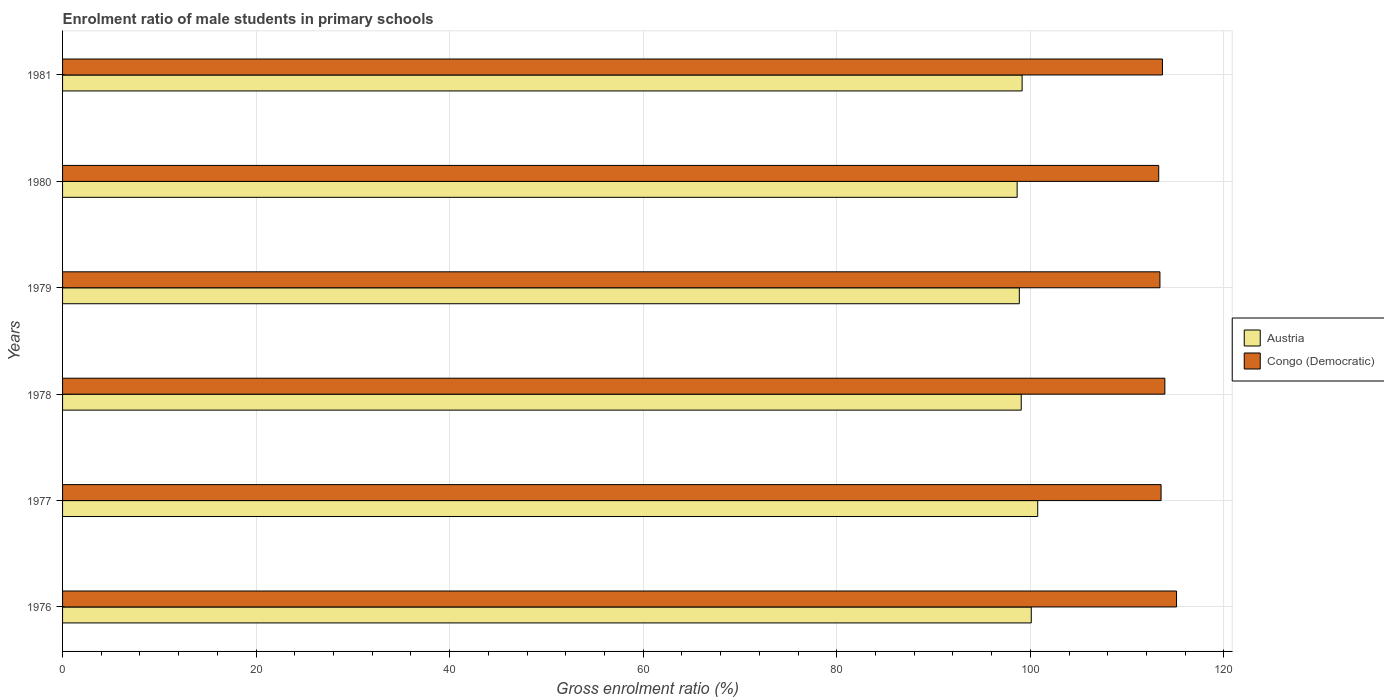Are the number of bars per tick equal to the number of legend labels?
Provide a short and direct response. Yes. Are the number of bars on each tick of the Y-axis equal?
Your response must be concise. Yes. How many bars are there on the 4th tick from the bottom?
Ensure brevity in your answer.  2. What is the label of the 4th group of bars from the top?
Provide a succinct answer. 1978. In how many cases, is the number of bars for a given year not equal to the number of legend labels?
Provide a succinct answer. 0. What is the enrolment ratio of male students in primary schools in Austria in 1981?
Give a very brief answer. 99.15. Across all years, what is the maximum enrolment ratio of male students in primary schools in Congo (Democratic)?
Offer a terse response. 115.11. Across all years, what is the minimum enrolment ratio of male students in primary schools in Austria?
Keep it short and to the point. 98.64. In which year was the enrolment ratio of male students in primary schools in Austria minimum?
Keep it short and to the point. 1980. What is the total enrolment ratio of male students in primary schools in Austria in the graph?
Your answer should be compact. 596.57. What is the difference between the enrolment ratio of male students in primary schools in Austria in 1976 and that in 1979?
Your answer should be compact. 1.24. What is the difference between the enrolment ratio of male students in primary schools in Congo (Democratic) in 1980 and the enrolment ratio of male students in primary schools in Austria in 1976?
Give a very brief answer. 13.17. What is the average enrolment ratio of male students in primary schools in Austria per year?
Make the answer very short. 99.43. In the year 1980, what is the difference between the enrolment ratio of male students in primary schools in Congo (Democratic) and enrolment ratio of male students in primary schools in Austria?
Provide a succinct answer. 14.63. In how many years, is the enrolment ratio of male students in primary schools in Congo (Democratic) greater than 88 %?
Your response must be concise. 6. What is the ratio of the enrolment ratio of male students in primary schools in Austria in 1979 to that in 1980?
Your response must be concise. 1. Is the enrolment ratio of male students in primary schools in Congo (Democratic) in 1978 less than that in 1980?
Your response must be concise. No. Is the difference between the enrolment ratio of male students in primary schools in Congo (Democratic) in 1976 and 1977 greater than the difference between the enrolment ratio of male students in primary schools in Austria in 1976 and 1977?
Ensure brevity in your answer.  Yes. What is the difference between the highest and the second highest enrolment ratio of male students in primary schools in Congo (Democratic)?
Provide a short and direct response. 1.21. What is the difference between the highest and the lowest enrolment ratio of male students in primary schools in Austria?
Your answer should be compact. 2.13. Is the sum of the enrolment ratio of male students in primary schools in Congo (Democratic) in 1976 and 1979 greater than the maximum enrolment ratio of male students in primary schools in Austria across all years?
Your answer should be very brief. Yes. What does the 1st bar from the top in 1980 represents?
Keep it short and to the point. Congo (Democratic). What does the 1st bar from the bottom in 1976 represents?
Provide a short and direct response. Austria. Are all the bars in the graph horizontal?
Keep it short and to the point. Yes. How many years are there in the graph?
Offer a very short reply. 6. What is the difference between two consecutive major ticks on the X-axis?
Provide a succinct answer. 20. Are the values on the major ticks of X-axis written in scientific E-notation?
Your response must be concise. No. Does the graph contain grids?
Provide a succinct answer. Yes. How many legend labels are there?
Offer a very short reply. 2. What is the title of the graph?
Make the answer very short. Enrolment ratio of male students in primary schools. What is the label or title of the Y-axis?
Keep it short and to the point. Years. What is the Gross enrolment ratio (%) of Austria in 1976?
Your answer should be very brief. 100.1. What is the Gross enrolment ratio (%) of Congo (Democratic) in 1976?
Provide a short and direct response. 115.11. What is the Gross enrolment ratio (%) of Austria in 1977?
Provide a succinct answer. 100.76. What is the Gross enrolment ratio (%) in Congo (Democratic) in 1977?
Keep it short and to the point. 113.51. What is the Gross enrolment ratio (%) in Austria in 1978?
Offer a terse response. 99.06. What is the Gross enrolment ratio (%) in Congo (Democratic) in 1978?
Your response must be concise. 113.9. What is the Gross enrolment ratio (%) of Austria in 1979?
Ensure brevity in your answer.  98.86. What is the Gross enrolment ratio (%) in Congo (Democratic) in 1979?
Make the answer very short. 113.39. What is the Gross enrolment ratio (%) in Austria in 1980?
Provide a succinct answer. 98.64. What is the Gross enrolment ratio (%) in Congo (Democratic) in 1980?
Your answer should be compact. 113.27. What is the Gross enrolment ratio (%) in Austria in 1981?
Provide a short and direct response. 99.15. What is the Gross enrolment ratio (%) of Congo (Democratic) in 1981?
Offer a terse response. 113.65. Across all years, what is the maximum Gross enrolment ratio (%) in Austria?
Keep it short and to the point. 100.76. Across all years, what is the maximum Gross enrolment ratio (%) in Congo (Democratic)?
Ensure brevity in your answer.  115.11. Across all years, what is the minimum Gross enrolment ratio (%) in Austria?
Ensure brevity in your answer.  98.64. Across all years, what is the minimum Gross enrolment ratio (%) in Congo (Democratic)?
Give a very brief answer. 113.27. What is the total Gross enrolment ratio (%) in Austria in the graph?
Offer a terse response. 596.57. What is the total Gross enrolment ratio (%) in Congo (Democratic) in the graph?
Your response must be concise. 682.83. What is the difference between the Gross enrolment ratio (%) in Austria in 1976 and that in 1977?
Provide a short and direct response. -0.67. What is the difference between the Gross enrolment ratio (%) of Congo (Democratic) in 1976 and that in 1977?
Offer a terse response. 1.6. What is the difference between the Gross enrolment ratio (%) in Austria in 1976 and that in 1978?
Provide a succinct answer. 1.04. What is the difference between the Gross enrolment ratio (%) of Congo (Democratic) in 1976 and that in 1978?
Keep it short and to the point. 1.21. What is the difference between the Gross enrolment ratio (%) in Austria in 1976 and that in 1979?
Your answer should be very brief. 1.24. What is the difference between the Gross enrolment ratio (%) in Congo (Democratic) in 1976 and that in 1979?
Your response must be concise. 1.72. What is the difference between the Gross enrolment ratio (%) of Austria in 1976 and that in 1980?
Your answer should be compact. 1.46. What is the difference between the Gross enrolment ratio (%) in Congo (Democratic) in 1976 and that in 1980?
Your answer should be very brief. 1.84. What is the difference between the Gross enrolment ratio (%) of Austria in 1976 and that in 1981?
Give a very brief answer. 0.94. What is the difference between the Gross enrolment ratio (%) of Congo (Democratic) in 1976 and that in 1981?
Keep it short and to the point. 1.45. What is the difference between the Gross enrolment ratio (%) in Austria in 1977 and that in 1978?
Offer a terse response. 1.7. What is the difference between the Gross enrolment ratio (%) in Congo (Democratic) in 1977 and that in 1978?
Your answer should be compact. -0.39. What is the difference between the Gross enrolment ratio (%) of Austria in 1977 and that in 1979?
Offer a very short reply. 1.9. What is the difference between the Gross enrolment ratio (%) in Congo (Democratic) in 1977 and that in 1979?
Your answer should be very brief. 0.12. What is the difference between the Gross enrolment ratio (%) in Austria in 1977 and that in 1980?
Provide a succinct answer. 2.13. What is the difference between the Gross enrolment ratio (%) of Congo (Democratic) in 1977 and that in 1980?
Ensure brevity in your answer.  0.24. What is the difference between the Gross enrolment ratio (%) of Austria in 1977 and that in 1981?
Offer a very short reply. 1.61. What is the difference between the Gross enrolment ratio (%) in Congo (Democratic) in 1977 and that in 1981?
Offer a terse response. -0.14. What is the difference between the Gross enrolment ratio (%) of Austria in 1978 and that in 1979?
Make the answer very short. 0.2. What is the difference between the Gross enrolment ratio (%) of Congo (Democratic) in 1978 and that in 1979?
Give a very brief answer. 0.51. What is the difference between the Gross enrolment ratio (%) of Austria in 1978 and that in 1980?
Ensure brevity in your answer.  0.42. What is the difference between the Gross enrolment ratio (%) of Congo (Democratic) in 1978 and that in 1980?
Your answer should be very brief. 0.63. What is the difference between the Gross enrolment ratio (%) in Austria in 1978 and that in 1981?
Your answer should be very brief. -0.09. What is the difference between the Gross enrolment ratio (%) of Congo (Democratic) in 1978 and that in 1981?
Ensure brevity in your answer.  0.25. What is the difference between the Gross enrolment ratio (%) in Austria in 1979 and that in 1980?
Offer a terse response. 0.22. What is the difference between the Gross enrolment ratio (%) of Congo (Democratic) in 1979 and that in 1980?
Your answer should be compact. 0.13. What is the difference between the Gross enrolment ratio (%) in Austria in 1979 and that in 1981?
Give a very brief answer. -0.29. What is the difference between the Gross enrolment ratio (%) in Congo (Democratic) in 1979 and that in 1981?
Keep it short and to the point. -0.26. What is the difference between the Gross enrolment ratio (%) in Austria in 1980 and that in 1981?
Keep it short and to the point. -0.51. What is the difference between the Gross enrolment ratio (%) of Congo (Democratic) in 1980 and that in 1981?
Make the answer very short. -0.39. What is the difference between the Gross enrolment ratio (%) in Austria in 1976 and the Gross enrolment ratio (%) in Congo (Democratic) in 1977?
Ensure brevity in your answer.  -13.41. What is the difference between the Gross enrolment ratio (%) in Austria in 1976 and the Gross enrolment ratio (%) in Congo (Democratic) in 1978?
Your answer should be very brief. -13.8. What is the difference between the Gross enrolment ratio (%) in Austria in 1976 and the Gross enrolment ratio (%) in Congo (Democratic) in 1979?
Your answer should be compact. -13.3. What is the difference between the Gross enrolment ratio (%) in Austria in 1976 and the Gross enrolment ratio (%) in Congo (Democratic) in 1980?
Ensure brevity in your answer.  -13.17. What is the difference between the Gross enrolment ratio (%) of Austria in 1976 and the Gross enrolment ratio (%) of Congo (Democratic) in 1981?
Keep it short and to the point. -13.56. What is the difference between the Gross enrolment ratio (%) in Austria in 1977 and the Gross enrolment ratio (%) in Congo (Democratic) in 1978?
Provide a short and direct response. -13.14. What is the difference between the Gross enrolment ratio (%) of Austria in 1977 and the Gross enrolment ratio (%) of Congo (Democratic) in 1979?
Keep it short and to the point. -12.63. What is the difference between the Gross enrolment ratio (%) in Austria in 1977 and the Gross enrolment ratio (%) in Congo (Democratic) in 1980?
Offer a terse response. -12.5. What is the difference between the Gross enrolment ratio (%) in Austria in 1977 and the Gross enrolment ratio (%) in Congo (Democratic) in 1981?
Give a very brief answer. -12.89. What is the difference between the Gross enrolment ratio (%) of Austria in 1978 and the Gross enrolment ratio (%) of Congo (Democratic) in 1979?
Your response must be concise. -14.33. What is the difference between the Gross enrolment ratio (%) in Austria in 1978 and the Gross enrolment ratio (%) in Congo (Democratic) in 1980?
Give a very brief answer. -14.21. What is the difference between the Gross enrolment ratio (%) of Austria in 1978 and the Gross enrolment ratio (%) of Congo (Democratic) in 1981?
Ensure brevity in your answer.  -14.59. What is the difference between the Gross enrolment ratio (%) of Austria in 1979 and the Gross enrolment ratio (%) of Congo (Democratic) in 1980?
Give a very brief answer. -14.41. What is the difference between the Gross enrolment ratio (%) in Austria in 1979 and the Gross enrolment ratio (%) in Congo (Democratic) in 1981?
Provide a succinct answer. -14.79. What is the difference between the Gross enrolment ratio (%) in Austria in 1980 and the Gross enrolment ratio (%) in Congo (Democratic) in 1981?
Make the answer very short. -15.02. What is the average Gross enrolment ratio (%) of Austria per year?
Offer a very short reply. 99.43. What is the average Gross enrolment ratio (%) of Congo (Democratic) per year?
Your response must be concise. 113.81. In the year 1976, what is the difference between the Gross enrolment ratio (%) of Austria and Gross enrolment ratio (%) of Congo (Democratic)?
Give a very brief answer. -15.01. In the year 1977, what is the difference between the Gross enrolment ratio (%) of Austria and Gross enrolment ratio (%) of Congo (Democratic)?
Offer a terse response. -12.75. In the year 1978, what is the difference between the Gross enrolment ratio (%) in Austria and Gross enrolment ratio (%) in Congo (Democratic)?
Your answer should be compact. -14.84. In the year 1979, what is the difference between the Gross enrolment ratio (%) of Austria and Gross enrolment ratio (%) of Congo (Democratic)?
Offer a terse response. -14.53. In the year 1980, what is the difference between the Gross enrolment ratio (%) in Austria and Gross enrolment ratio (%) in Congo (Democratic)?
Ensure brevity in your answer.  -14.63. In the year 1981, what is the difference between the Gross enrolment ratio (%) in Austria and Gross enrolment ratio (%) in Congo (Democratic)?
Your answer should be very brief. -14.5. What is the ratio of the Gross enrolment ratio (%) of Austria in 1976 to that in 1977?
Offer a terse response. 0.99. What is the ratio of the Gross enrolment ratio (%) of Congo (Democratic) in 1976 to that in 1977?
Keep it short and to the point. 1.01. What is the ratio of the Gross enrolment ratio (%) of Austria in 1976 to that in 1978?
Your answer should be compact. 1.01. What is the ratio of the Gross enrolment ratio (%) of Congo (Democratic) in 1976 to that in 1978?
Provide a short and direct response. 1.01. What is the ratio of the Gross enrolment ratio (%) in Austria in 1976 to that in 1979?
Keep it short and to the point. 1.01. What is the ratio of the Gross enrolment ratio (%) in Congo (Democratic) in 1976 to that in 1979?
Your answer should be very brief. 1.02. What is the ratio of the Gross enrolment ratio (%) of Austria in 1976 to that in 1980?
Ensure brevity in your answer.  1.01. What is the ratio of the Gross enrolment ratio (%) in Congo (Democratic) in 1976 to that in 1980?
Your answer should be very brief. 1.02. What is the ratio of the Gross enrolment ratio (%) of Austria in 1976 to that in 1981?
Give a very brief answer. 1.01. What is the ratio of the Gross enrolment ratio (%) in Congo (Democratic) in 1976 to that in 1981?
Provide a succinct answer. 1.01. What is the ratio of the Gross enrolment ratio (%) in Austria in 1977 to that in 1978?
Give a very brief answer. 1.02. What is the ratio of the Gross enrolment ratio (%) of Austria in 1977 to that in 1979?
Give a very brief answer. 1.02. What is the ratio of the Gross enrolment ratio (%) of Austria in 1977 to that in 1980?
Provide a succinct answer. 1.02. What is the ratio of the Gross enrolment ratio (%) of Austria in 1977 to that in 1981?
Your answer should be very brief. 1.02. What is the ratio of the Gross enrolment ratio (%) in Congo (Democratic) in 1977 to that in 1981?
Your answer should be compact. 1. What is the ratio of the Gross enrolment ratio (%) of Congo (Democratic) in 1978 to that in 1979?
Provide a succinct answer. 1. What is the ratio of the Gross enrolment ratio (%) of Congo (Democratic) in 1978 to that in 1980?
Your response must be concise. 1.01. What is the ratio of the Gross enrolment ratio (%) in Austria in 1978 to that in 1981?
Provide a succinct answer. 1. What is the ratio of the Gross enrolment ratio (%) of Austria in 1979 to that in 1980?
Make the answer very short. 1. What is the ratio of the Gross enrolment ratio (%) of Congo (Democratic) in 1979 to that in 1980?
Provide a succinct answer. 1. What is the ratio of the Gross enrolment ratio (%) of Austria in 1979 to that in 1981?
Provide a succinct answer. 1. What is the ratio of the Gross enrolment ratio (%) in Austria in 1980 to that in 1981?
Offer a very short reply. 0.99. What is the ratio of the Gross enrolment ratio (%) in Congo (Democratic) in 1980 to that in 1981?
Make the answer very short. 1. What is the difference between the highest and the second highest Gross enrolment ratio (%) of Congo (Democratic)?
Your response must be concise. 1.21. What is the difference between the highest and the lowest Gross enrolment ratio (%) in Austria?
Keep it short and to the point. 2.13. What is the difference between the highest and the lowest Gross enrolment ratio (%) in Congo (Democratic)?
Give a very brief answer. 1.84. 